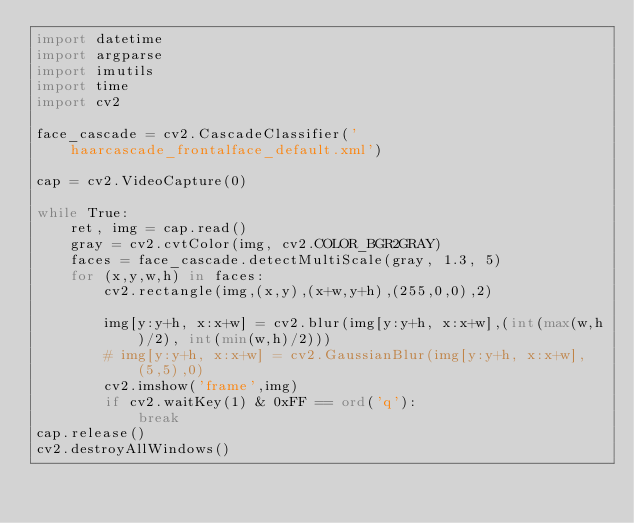<code> <loc_0><loc_0><loc_500><loc_500><_Python_>import datetime
import argparse
import imutils
import time
import cv2

face_cascade = cv2.CascadeClassifier('haarcascade_frontalface_default.xml')

cap = cv2.VideoCapture(0)

while True:
    ret, img = cap.read()
    gray = cv2.cvtColor(img, cv2.COLOR_BGR2GRAY)
    faces = face_cascade.detectMultiScale(gray, 1.3, 5)
    for (x,y,w,h) in faces:
        cv2.rectangle(img,(x,y),(x+w,y+h),(255,0,0),2)

        img[y:y+h, x:x+w] = cv2.blur(img[y:y+h, x:x+w],(int(max(w,h)/2), int(min(w,h)/2)))
        # img[y:y+h, x:x+w] = cv2.GaussianBlur(img[y:y+h, x:x+w], (5,5),0)
        cv2.imshow('frame',img)
        if cv2.waitKey(1) & 0xFF == ord('q'):
            break
cap.release()
cv2.destroyAllWindows()
</code> 